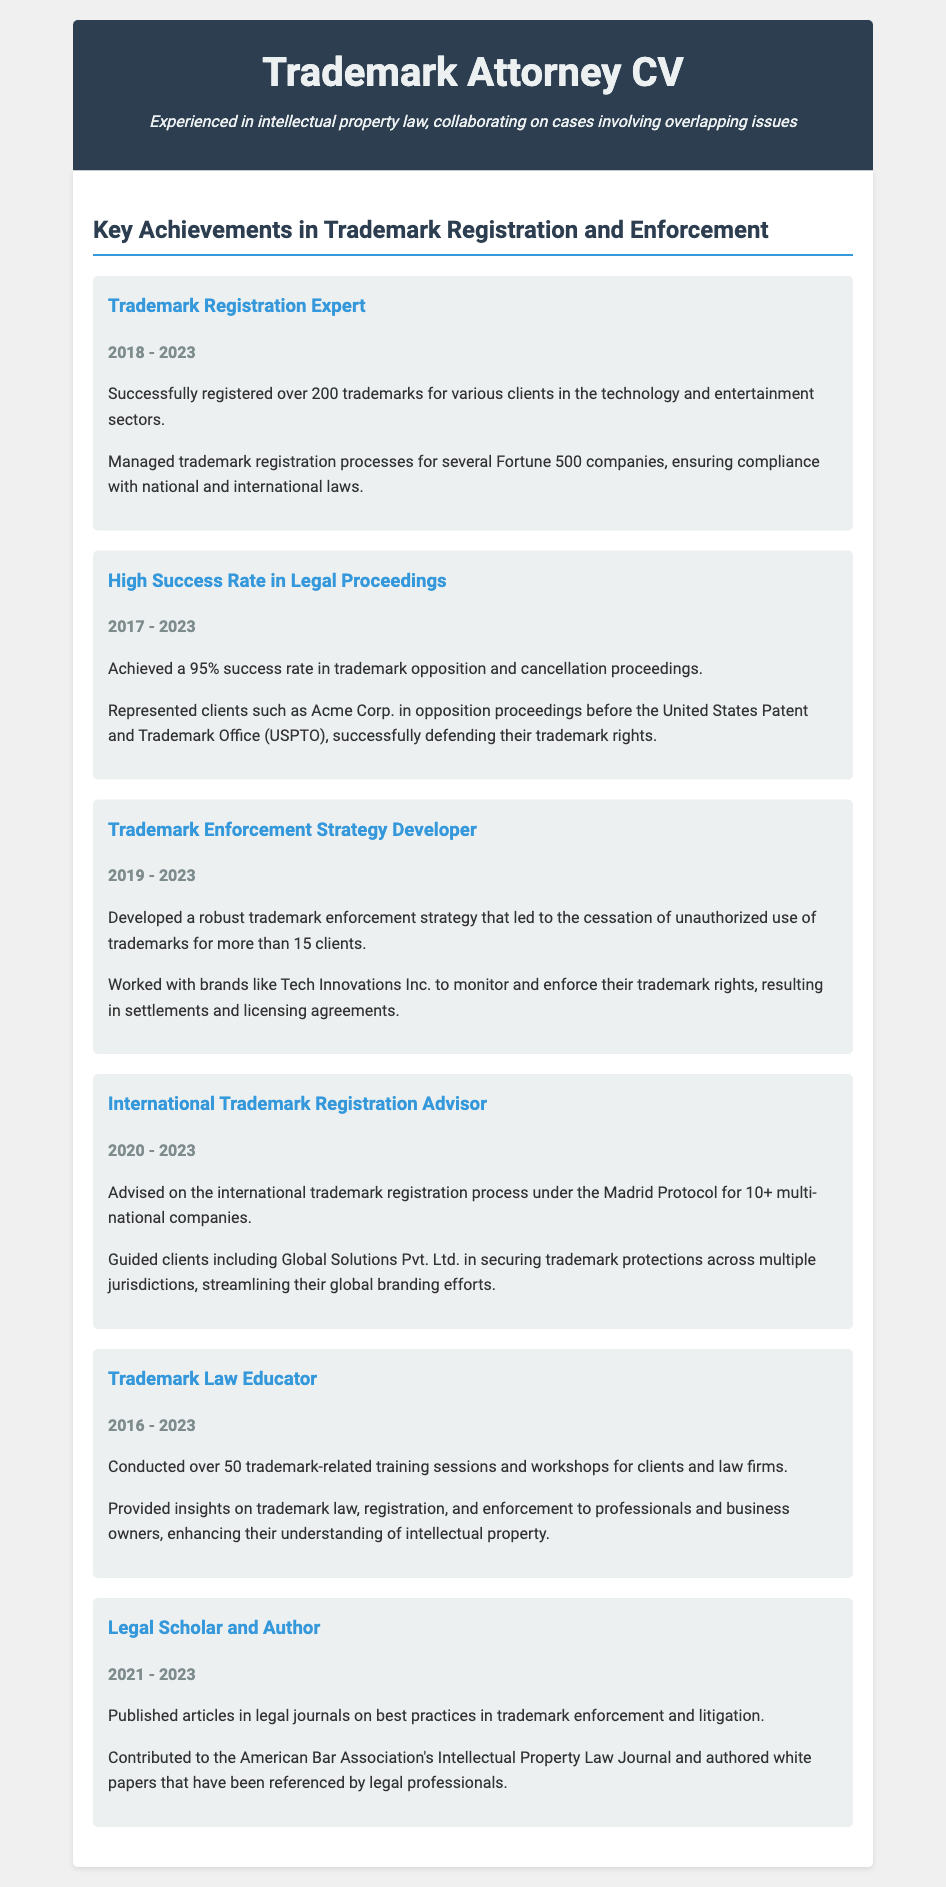What is the total number of trademarks registered? The total number of trademarks registered is 200, as mentioned in the achievements.
Answer: 200 What is the success rate in trademark proceedings? The success rate in trademark opposition and cancellation proceedings is stated as 95%.
Answer: 95% Which years encompass the trademark registration expertise? The years covering trademark registration expertise are from 2018 to 2023.
Answer: 2018 - 2023 Who represented Acme Corp. in opposition proceedings? The document states that the attorney represented Acme Corp. in opposition proceedings.
Answer: Attorney How many training sessions were conducted by the trademark law educator? The educator conducted over 50 trademark-related training sessions, according to the text.
Answer: over 50 What strategy was developed for clients regarding unauthorized trademark use? The document describes a trademark enforcement strategy developed for clients.
Answer: trademark enforcement strategy How many multi-national companies received advice on international trademark registration? The document indicates that advice was given to over 10 multi-national companies.
Answer: 10+ What type of articles did the legal scholar publish? The legal scholar published articles on best practices in trademark enforcement and litigation.
Answer: best practices in trademark enforcement and litigation What is the time frame for the trademark enforcement strategy development? The time frame for the trademark enforcement strategy development spans from 2019 to 2023.
Answer: 2019 - 2023 